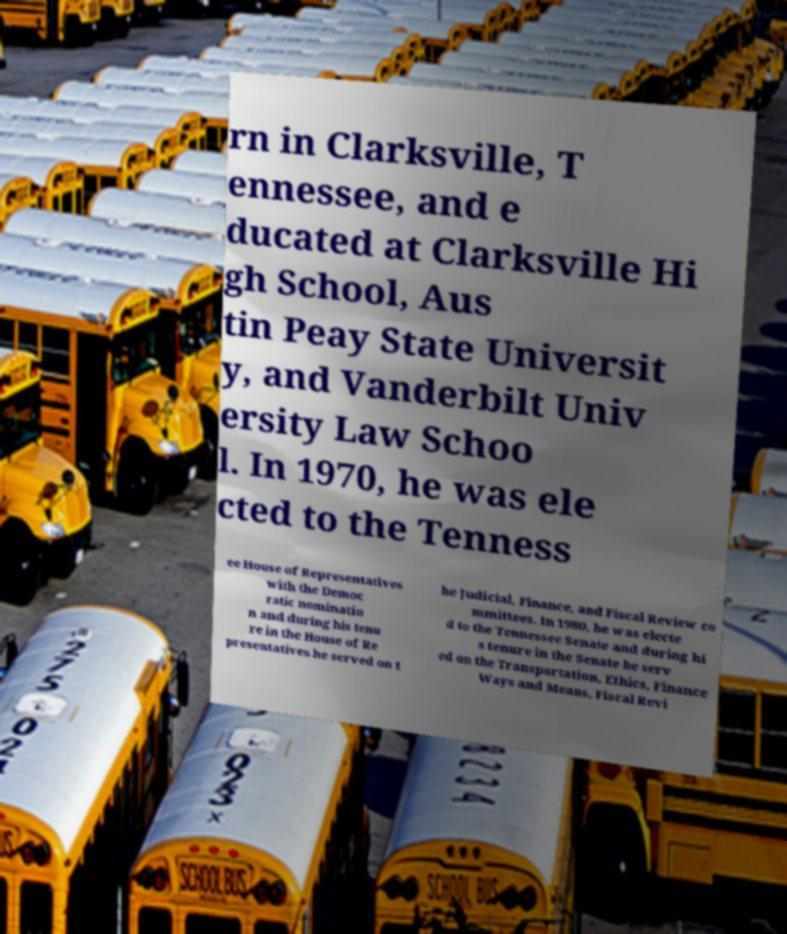I need the written content from this picture converted into text. Can you do that? rn in Clarksville, T ennessee, and e ducated at Clarksville Hi gh School, Aus tin Peay State Universit y, and Vanderbilt Univ ersity Law Schoo l. In 1970, he was ele cted to the Tenness ee House of Representatives with the Democ ratic nominatio n and during his tenu re in the House of Re presentatives he served on t he Judicial, Finance, and Fiscal Review co mmittees. In 1980, he was electe d to the Tennessee Senate and during hi s tenure in the Senate he serv ed on the Transportation, Ethics, Finance Ways and Means, Fiscal Revi 